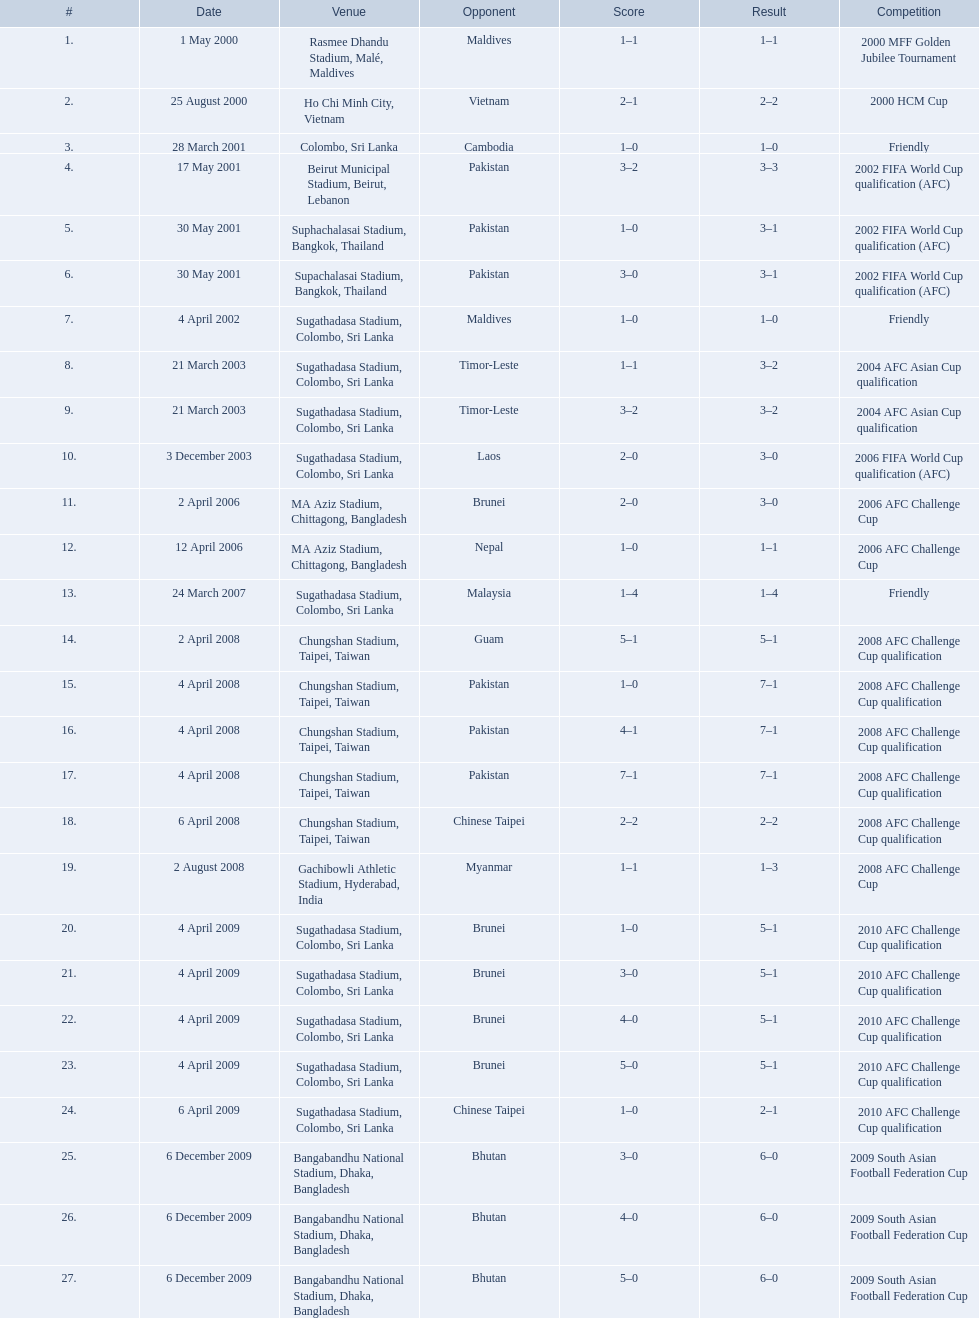What are the venues Rasmee Dhandu Stadium, Malé, Maldives, Ho Chi Minh City, Vietnam, Colombo, Sri Lanka, Beirut Municipal Stadium, Beirut, Lebanon, Suphachalasai Stadium, Bangkok, Thailand, Supachalasai Stadium, Bangkok, Thailand, Sugathadasa Stadium, Colombo, Sri Lanka, Sugathadasa Stadium, Colombo, Sri Lanka, Sugathadasa Stadium, Colombo, Sri Lanka, Sugathadasa Stadium, Colombo, Sri Lanka, MA Aziz Stadium, Chittagong, Bangladesh, MA Aziz Stadium, Chittagong, Bangladesh, Sugathadasa Stadium, Colombo, Sri Lanka, Chungshan Stadium, Taipei, Taiwan, Chungshan Stadium, Taipei, Taiwan, Chungshan Stadium, Taipei, Taiwan, Chungshan Stadium, Taipei, Taiwan, Chungshan Stadium, Taipei, Taiwan, Gachibowli Athletic Stadium, Hyderabad, India, Sugathadasa Stadium, Colombo, Sri Lanka, Sugathadasa Stadium, Colombo, Sri Lanka, Sugathadasa Stadium, Colombo, Sri Lanka, Sugathadasa Stadium, Colombo, Sri Lanka, Sugathadasa Stadium, Colombo, Sri Lanka, Bangabandhu National Stadium, Dhaka, Bangladesh, Bangabandhu National Stadium, Dhaka, Bangladesh, Bangabandhu National Stadium, Dhaka, Bangladesh. What are the #'s? 1., 2., 3., 4., 5., 6., 7., 8., 9., 10., 11., 12., 13., 14., 15., 16., 17., 18., 19., 20., 21., 22., 23., 24., 25., 26., 27. Which one is #1? Rasmee Dhandu Stadium, Malé, Maldives. 